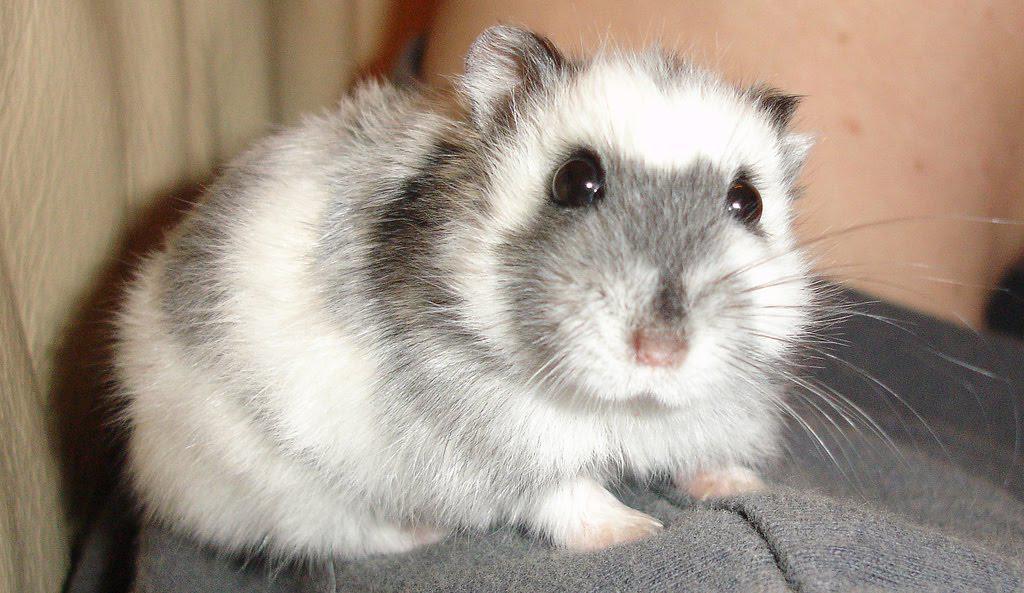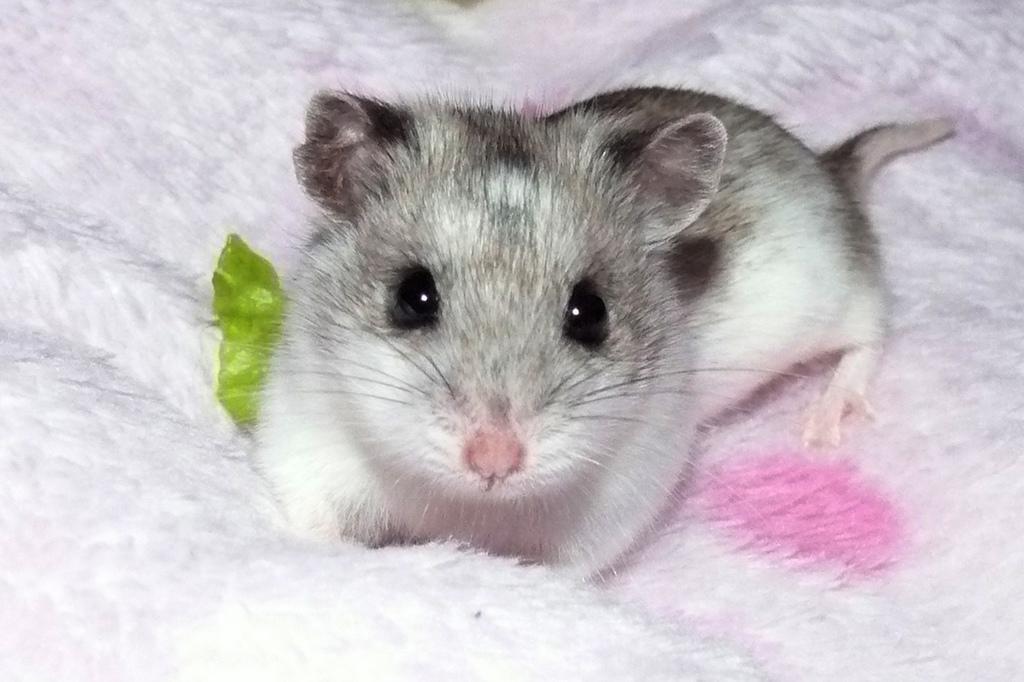The first image is the image on the left, the second image is the image on the right. For the images shown, is this caption "at least one hamster in on wood shavings" true? Answer yes or no. No. The first image is the image on the left, the second image is the image on the right. Evaluate the accuracy of this statement regarding the images: "There are 2 white mice next to each other.". Is it true? Answer yes or no. No. 